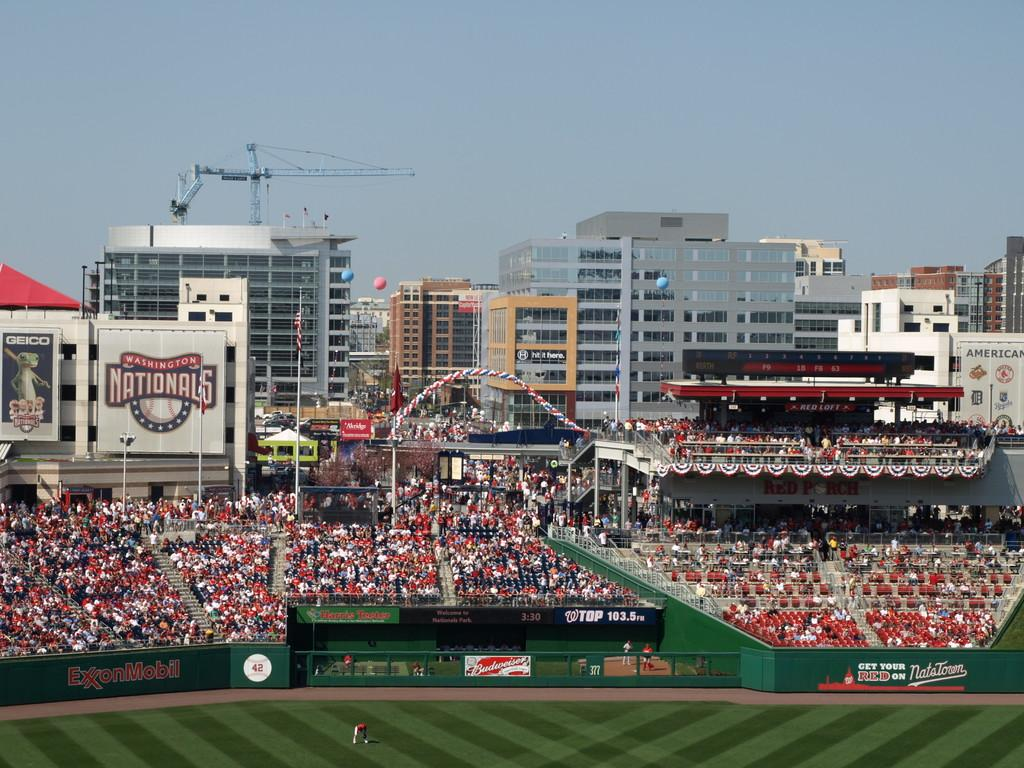<image>
Offer a succinct explanation of the picture presented. The day is sunny at the ballpark where the Nationals play. 